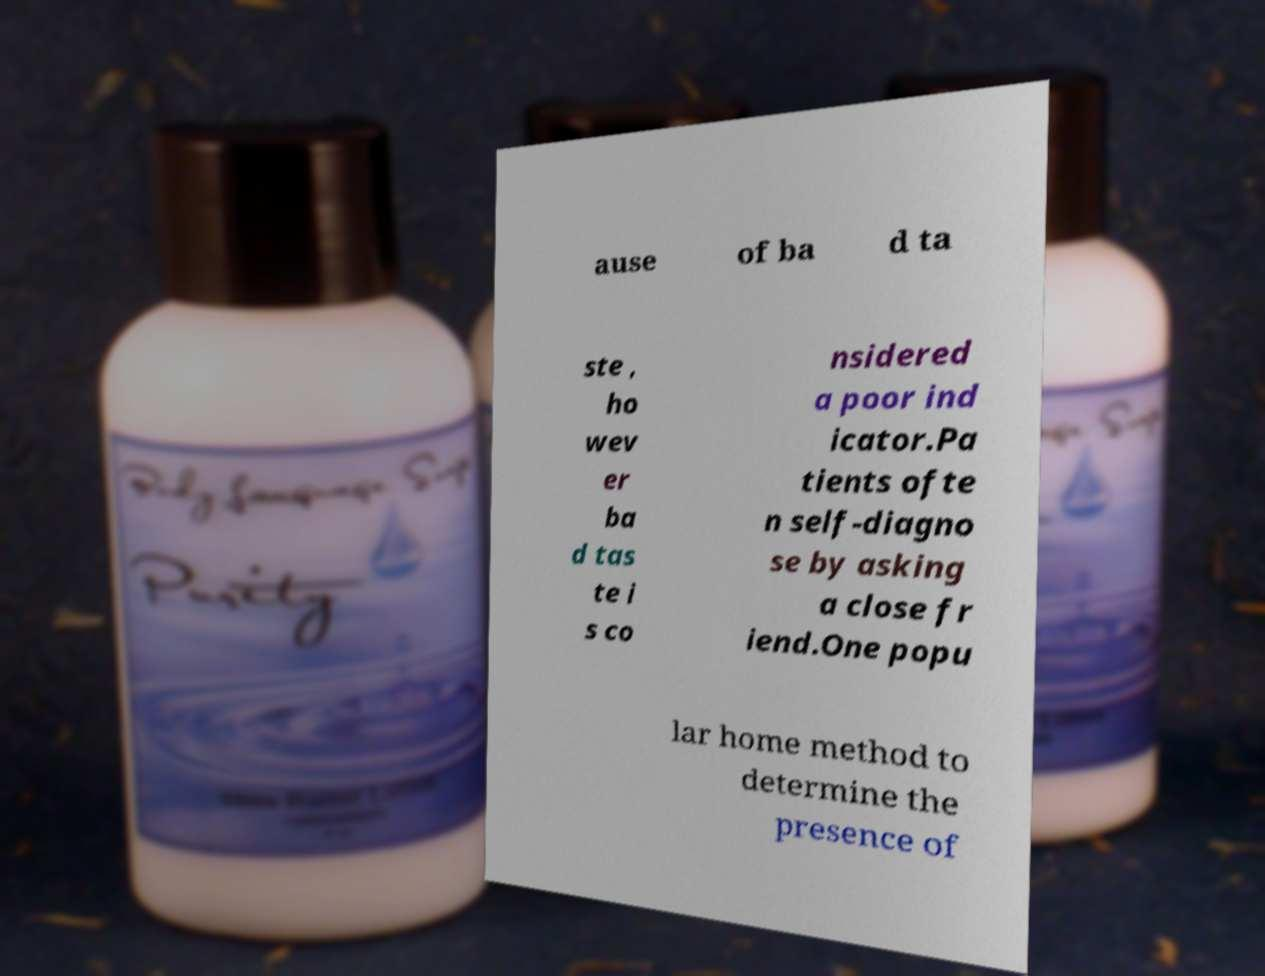There's text embedded in this image that I need extracted. Can you transcribe it verbatim? ause of ba d ta ste , ho wev er ba d tas te i s co nsidered a poor ind icator.Pa tients ofte n self-diagno se by asking a close fr iend.One popu lar home method to determine the presence of 